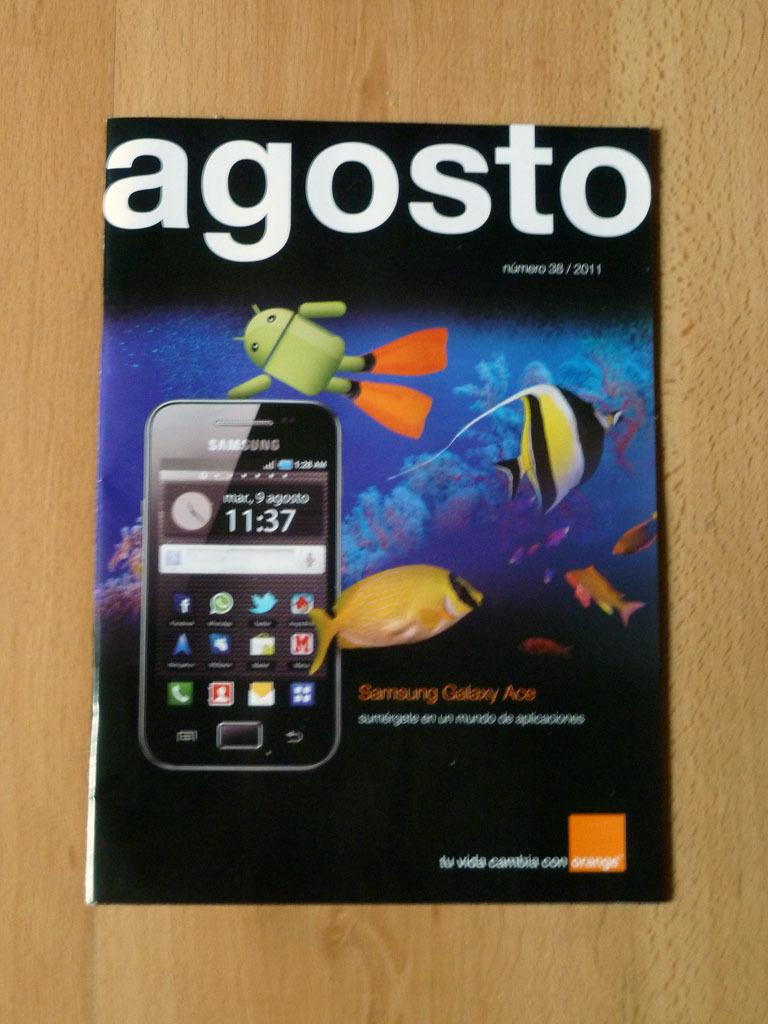What is present on the wooden surface in the image? There is a poster on the wooden surface in the image. What can be found on the poster? The poster contains images and text. Can you describe the poster's content? The poster contains images and text, but the specific content cannot be determined from the provided facts. What type of steel is used to create the pet's anger in the image? There is no steel, pet, or anger present in the image. The image only contains a poster on a wooden surface with images and text. 